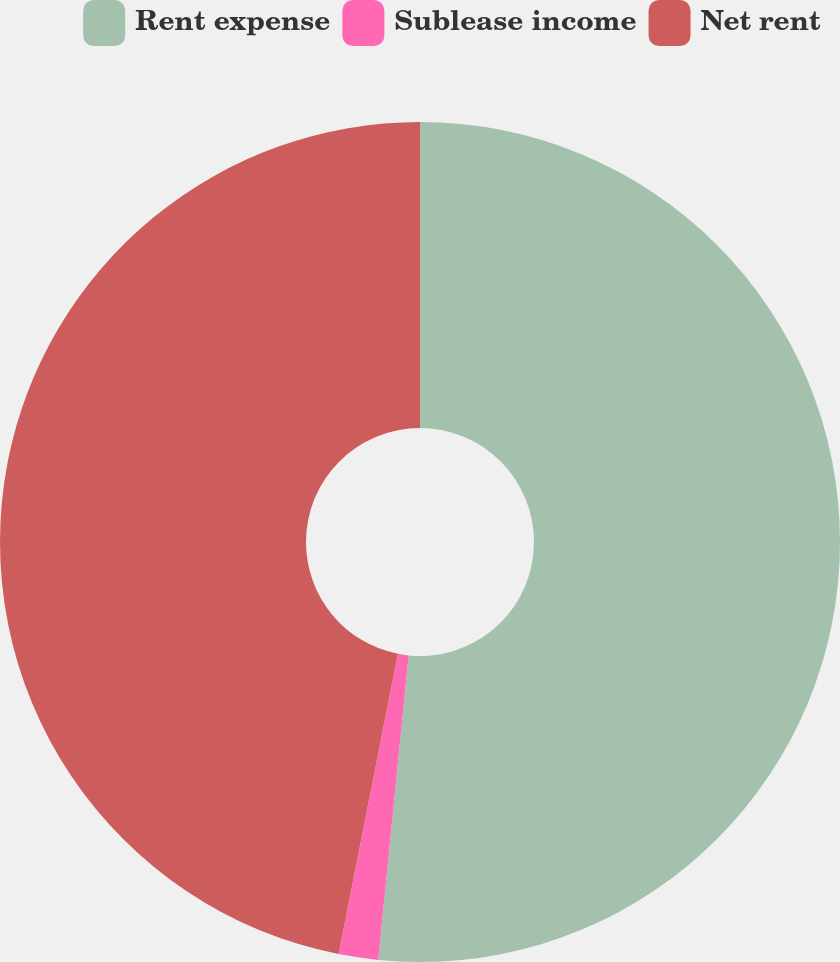Convert chart. <chart><loc_0><loc_0><loc_500><loc_500><pie_chart><fcel>Rent expense<fcel>Sublease income<fcel>Net rent<nl><fcel>51.59%<fcel>1.52%<fcel>46.9%<nl></chart> 